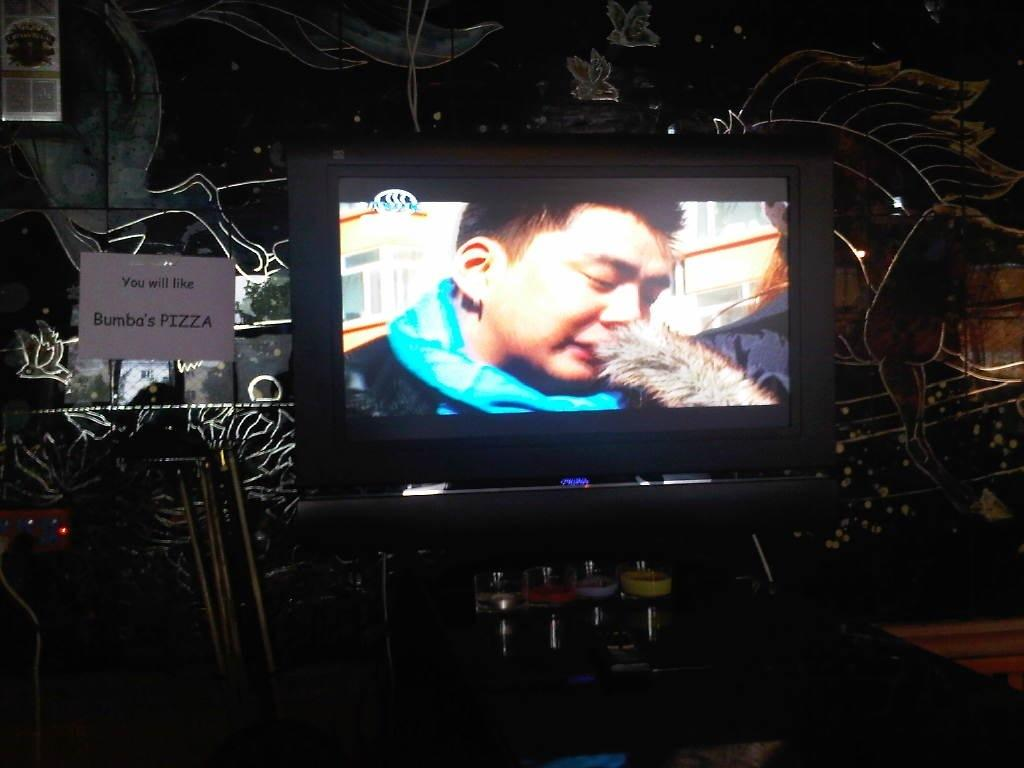What electronic device can be seen in the image? There is a monitor in the image. What is displayed on the monitor? A person is visible on the monitor. What is located on the wall in the image? There is a socket on the wall in the image. What type of object can be seen in the image that is typically used for writing or reading? There is a paper in the image. What type of object can be seen in the image that is typically used for holding liquids? There are glasses in the image. How would you describe the lighting in the image? The background of the image is dark. How does the person on the monitor say good-bye to the airplane in the image? There is no airplane present in the image, and the person on the monitor cannot interact with the image itself. 